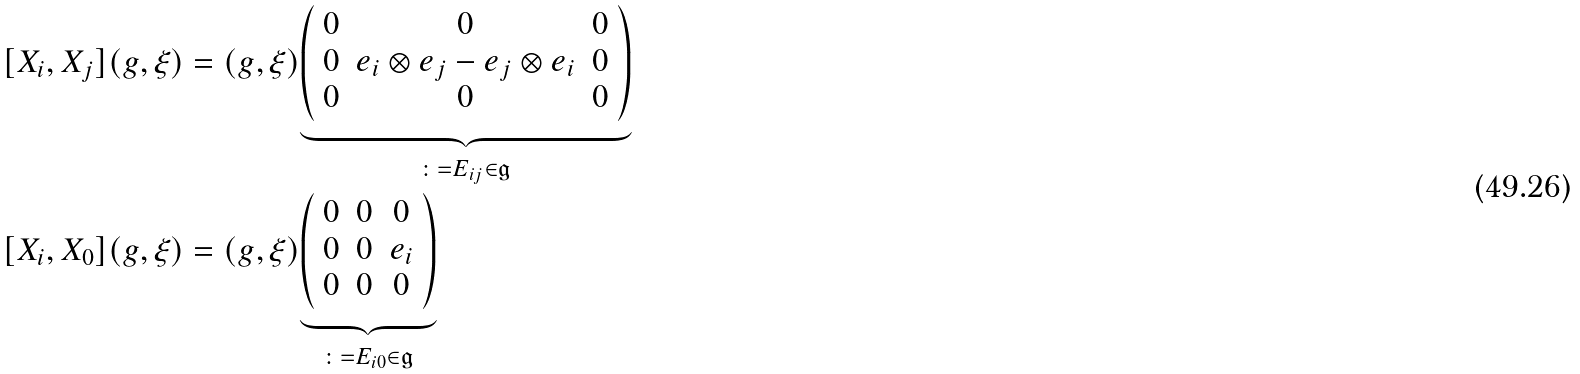<formula> <loc_0><loc_0><loc_500><loc_500>[ X _ { i } , X _ { j } ] ( g , \xi ) & = ( g , \xi ) \underset { \colon = E _ { i j } \in \mathfrak { g } } { \underbrace { \left ( \begin{array} { c c c } 0 & 0 & 0 \\ 0 & e _ { i } \otimes e _ { j } - e _ { j } \otimes e _ { i } & 0 \\ 0 & 0 & 0 \end{array} \right ) } } \\ [ X _ { i } , X _ { 0 } ] ( g , \xi ) & = ( g , \xi ) \underset { \colon = E _ { i 0 } \in \mathfrak { g } } { \underbrace { \left ( \begin{array} { c c c } 0 & 0 & 0 \\ 0 & 0 & e _ { i } \\ 0 & 0 & 0 \end{array} \right ) } } \\</formula> 